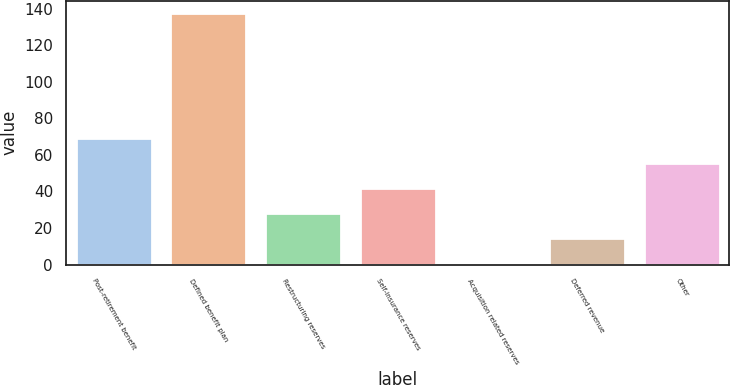<chart> <loc_0><loc_0><loc_500><loc_500><bar_chart><fcel>Post-retirement benefit<fcel>Defined benefit plan<fcel>Restructuring reserves<fcel>Self-insurance reserves<fcel>Acquisition related reserves<fcel>Deferred revenue<fcel>Other<nl><fcel>69.05<fcel>137.5<fcel>27.98<fcel>41.67<fcel>0.6<fcel>14.29<fcel>55.36<nl></chart> 